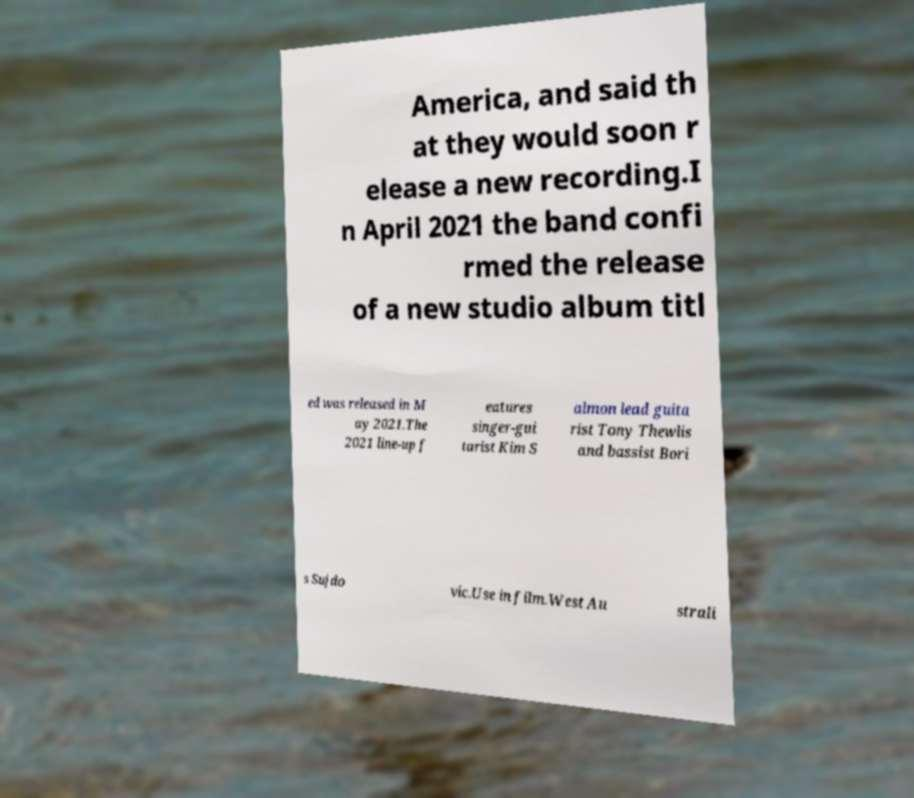Please identify and transcribe the text found in this image. America, and said th at they would soon r elease a new recording.I n April 2021 the band confi rmed the release of a new studio album titl ed was released in M ay 2021.The 2021 line-up f eatures singer-gui tarist Kim S almon lead guita rist Tony Thewlis and bassist Bori s Sujdo vic.Use in film.West Au strali 